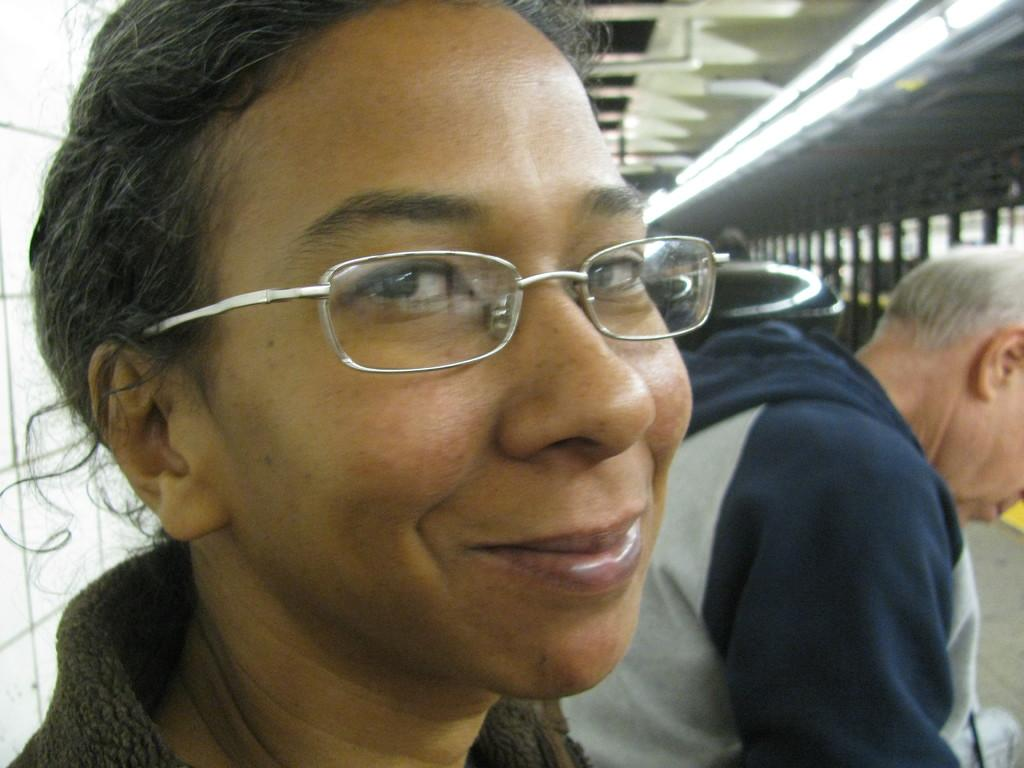What is the woman in the image wearing? The woman in the image is wearing spectacles. Where is the man located in the image? The man is sitting on the right side of the image. What type of lighting is present in the image? There are ceiling lights visible in the image. What can be seen through the windows in the image? The presence of windows suggests that there is a view of the outdoors or another room. Can you see a frog jumping in the image? There is no frog present in the image. Did the man bite the woman's spectacles in the image? There is no indication of any biting or conflict between the man and the woman in the image. 